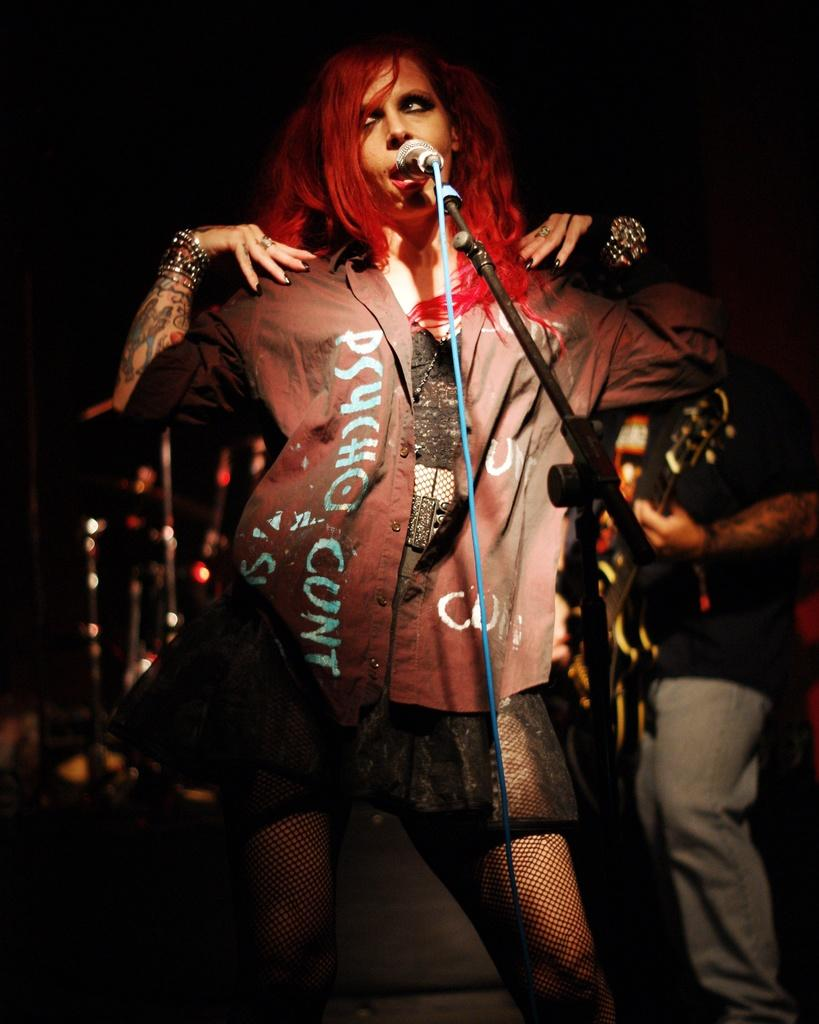What is the main subject of the image? There is a woman in the image. What is the woman doing in the image? The woman is standing and singing a song. What is the woman holding in the image? The woman is holding a microphone. How is the microphone positioned in the image? The microphone is in a stand. Can you describe the other person in the image? There is a person in the image, and they are standing and holding a guitar. What type of shop can be seen in the background of the image? There is no shop visible in the image; it features a woman singing with a microphone and a person playing a guitar. How many ants are crawling on the microphone in the image? There are no ants present in the image. 